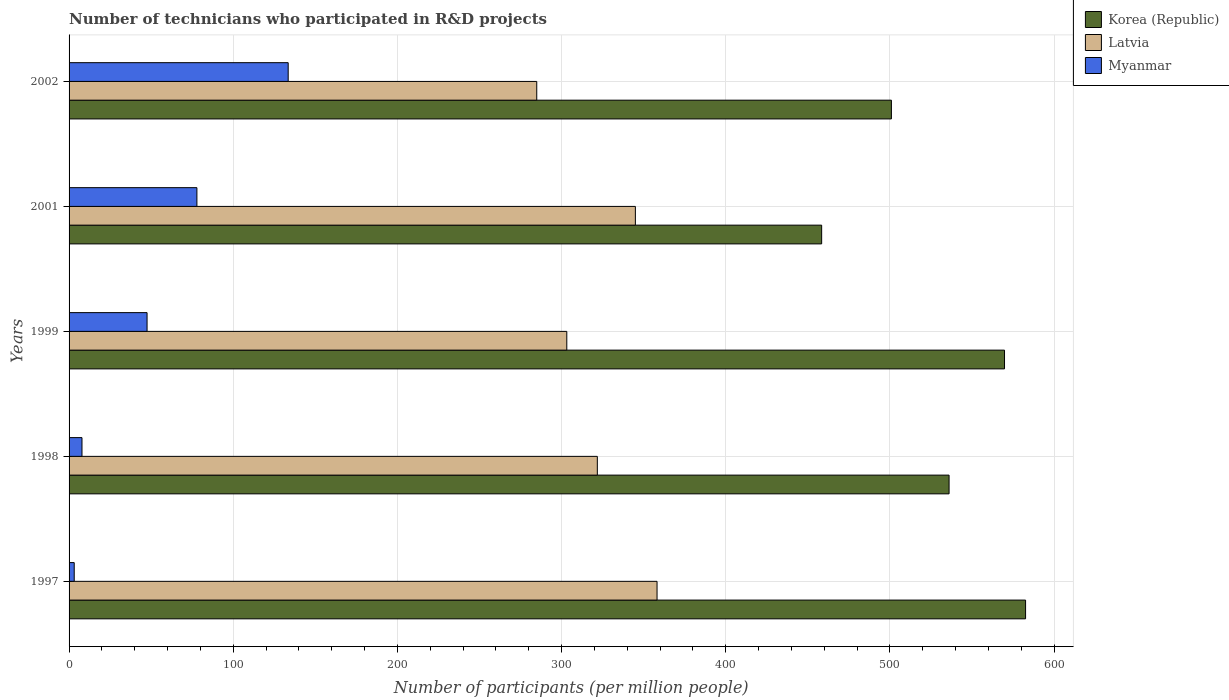How many different coloured bars are there?
Offer a terse response. 3. Are the number of bars per tick equal to the number of legend labels?
Ensure brevity in your answer.  Yes. What is the number of technicians who participated in R&D projects in Korea (Republic) in 2001?
Your response must be concise. 458.44. Across all years, what is the maximum number of technicians who participated in R&D projects in Korea (Republic)?
Make the answer very short. 582.66. Across all years, what is the minimum number of technicians who participated in R&D projects in Latvia?
Provide a succinct answer. 284.88. In which year was the number of technicians who participated in R&D projects in Korea (Republic) minimum?
Provide a short and direct response. 2001. What is the total number of technicians who participated in R&D projects in Latvia in the graph?
Offer a very short reply. 1613. What is the difference between the number of technicians who participated in R&D projects in Latvia in 2001 and that in 2002?
Offer a very short reply. 60.08. What is the difference between the number of technicians who participated in R&D projects in Myanmar in 2001 and the number of technicians who participated in R&D projects in Latvia in 1999?
Your answer should be compact. -225.32. What is the average number of technicians who participated in R&D projects in Myanmar per year?
Provide a succinct answer. 53.97. In the year 1998, what is the difference between the number of technicians who participated in R&D projects in Myanmar and number of technicians who participated in R&D projects in Korea (Republic)?
Keep it short and to the point. -528.19. What is the ratio of the number of technicians who participated in R&D projects in Korea (Republic) in 1998 to that in 1999?
Give a very brief answer. 0.94. Is the difference between the number of technicians who participated in R&D projects in Myanmar in 1998 and 2001 greater than the difference between the number of technicians who participated in R&D projects in Korea (Republic) in 1998 and 2001?
Offer a very short reply. No. What is the difference between the highest and the second highest number of technicians who participated in R&D projects in Myanmar?
Your response must be concise. 55.61. What is the difference between the highest and the lowest number of technicians who participated in R&D projects in Myanmar?
Ensure brevity in your answer.  130.34. In how many years, is the number of technicians who participated in R&D projects in Myanmar greater than the average number of technicians who participated in R&D projects in Myanmar taken over all years?
Give a very brief answer. 2. Is the sum of the number of technicians who participated in R&D projects in Korea (Republic) in 1997 and 1998 greater than the maximum number of technicians who participated in R&D projects in Latvia across all years?
Keep it short and to the point. Yes. What does the 1st bar from the top in 1999 represents?
Ensure brevity in your answer.  Myanmar. What does the 2nd bar from the bottom in 1998 represents?
Your answer should be compact. Latvia. Is it the case that in every year, the sum of the number of technicians who participated in R&D projects in Latvia and number of technicians who participated in R&D projects in Myanmar is greater than the number of technicians who participated in R&D projects in Korea (Republic)?
Your answer should be compact. No. How many bars are there?
Give a very brief answer. 15. How many years are there in the graph?
Provide a short and direct response. 5. What is the difference between two consecutive major ticks on the X-axis?
Offer a terse response. 100. Are the values on the major ticks of X-axis written in scientific E-notation?
Give a very brief answer. No. Does the graph contain grids?
Provide a succinct answer. Yes. How many legend labels are there?
Provide a short and direct response. 3. How are the legend labels stacked?
Your answer should be compact. Vertical. What is the title of the graph?
Ensure brevity in your answer.  Number of technicians who participated in R&D projects. What is the label or title of the X-axis?
Give a very brief answer. Number of participants (per million people). What is the label or title of the Y-axis?
Keep it short and to the point. Years. What is the Number of participants (per million people) of Korea (Republic) in 1997?
Ensure brevity in your answer.  582.66. What is the Number of participants (per million people) in Latvia in 1997?
Your answer should be very brief. 358.17. What is the Number of participants (per million people) of Myanmar in 1997?
Make the answer very short. 3.14. What is the Number of participants (per million people) of Korea (Republic) in 1998?
Keep it short and to the point. 536.06. What is the Number of participants (per million people) of Latvia in 1998?
Provide a succinct answer. 321.79. What is the Number of participants (per million people) in Myanmar in 1998?
Your answer should be very brief. 7.87. What is the Number of participants (per million people) in Korea (Republic) in 1999?
Provide a succinct answer. 569.83. What is the Number of participants (per million people) in Latvia in 1999?
Make the answer very short. 303.19. What is the Number of participants (per million people) of Myanmar in 1999?
Give a very brief answer. 47.51. What is the Number of participants (per million people) in Korea (Republic) in 2001?
Offer a very short reply. 458.44. What is the Number of participants (per million people) of Latvia in 2001?
Provide a short and direct response. 344.97. What is the Number of participants (per million people) of Myanmar in 2001?
Provide a short and direct response. 77.87. What is the Number of participants (per million people) of Korea (Republic) in 2002?
Your response must be concise. 500.92. What is the Number of participants (per million people) of Latvia in 2002?
Offer a very short reply. 284.88. What is the Number of participants (per million people) of Myanmar in 2002?
Provide a short and direct response. 133.48. Across all years, what is the maximum Number of participants (per million people) of Korea (Republic)?
Your answer should be compact. 582.66. Across all years, what is the maximum Number of participants (per million people) of Latvia?
Provide a succinct answer. 358.17. Across all years, what is the maximum Number of participants (per million people) of Myanmar?
Your answer should be compact. 133.48. Across all years, what is the minimum Number of participants (per million people) in Korea (Republic)?
Give a very brief answer. 458.44. Across all years, what is the minimum Number of participants (per million people) in Latvia?
Make the answer very short. 284.88. Across all years, what is the minimum Number of participants (per million people) of Myanmar?
Your response must be concise. 3.14. What is the total Number of participants (per million people) in Korea (Republic) in the graph?
Your answer should be very brief. 2647.91. What is the total Number of participants (per million people) in Latvia in the graph?
Provide a succinct answer. 1613. What is the total Number of participants (per million people) of Myanmar in the graph?
Give a very brief answer. 269.86. What is the difference between the Number of participants (per million people) in Korea (Republic) in 1997 and that in 1998?
Make the answer very short. 46.6. What is the difference between the Number of participants (per million people) in Latvia in 1997 and that in 1998?
Offer a terse response. 36.38. What is the difference between the Number of participants (per million people) in Myanmar in 1997 and that in 1998?
Your answer should be very brief. -4.73. What is the difference between the Number of participants (per million people) in Korea (Republic) in 1997 and that in 1999?
Keep it short and to the point. 12.83. What is the difference between the Number of participants (per million people) of Latvia in 1997 and that in 1999?
Keep it short and to the point. 54.97. What is the difference between the Number of participants (per million people) in Myanmar in 1997 and that in 1999?
Ensure brevity in your answer.  -44.37. What is the difference between the Number of participants (per million people) in Korea (Republic) in 1997 and that in 2001?
Keep it short and to the point. 124.22. What is the difference between the Number of participants (per million people) of Latvia in 1997 and that in 2001?
Your response must be concise. 13.2. What is the difference between the Number of participants (per million people) in Myanmar in 1997 and that in 2001?
Offer a very short reply. -74.73. What is the difference between the Number of participants (per million people) of Korea (Republic) in 1997 and that in 2002?
Ensure brevity in your answer.  81.73. What is the difference between the Number of participants (per million people) of Latvia in 1997 and that in 2002?
Keep it short and to the point. 73.28. What is the difference between the Number of participants (per million people) in Myanmar in 1997 and that in 2002?
Ensure brevity in your answer.  -130.34. What is the difference between the Number of participants (per million people) of Korea (Republic) in 1998 and that in 1999?
Ensure brevity in your answer.  -33.77. What is the difference between the Number of participants (per million people) in Latvia in 1998 and that in 1999?
Your answer should be compact. 18.59. What is the difference between the Number of participants (per million people) of Myanmar in 1998 and that in 1999?
Offer a terse response. -39.64. What is the difference between the Number of participants (per million people) in Korea (Republic) in 1998 and that in 2001?
Your answer should be compact. 77.62. What is the difference between the Number of participants (per million people) in Latvia in 1998 and that in 2001?
Your answer should be compact. -23.18. What is the difference between the Number of participants (per million people) of Myanmar in 1998 and that in 2001?
Offer a very short reply. -70. What is the difference between the Number of participants (per million people) of Korea (Republic) in 1998 and that in 2002?
Give a very brief answer. 35.13. What is the difference between the Number of participants (per million people) of Latvia in 1998 and that in 2002?
Keep it short and to the point. 36.9. What is the difference between the Number of participants (per million people) in Myanmar in 1998 and that in 2002?
Make the answer very short. -125.61. What is the difference between the Number of participants (per million people) of Korea (Republic) in 1999 and that in 2001?
Provide a succinct answer. 111.39. What is the difference between the Number of participants (per million people) of Latvia in 1999 and that in 2001?
Your answer should be very brief. -41.78. What is the difference between the Number of participants (per million people) of Myanmar in 1999 and that in 2001?
Your answer should be compact. -30.36. What is the difference between the Number of participants (per million people) of Korea (Republic) in 1999 and that in 2002?
Provide a succinct answer. 68.91. What is the difference between the Number of participants (per million people) in Latvia in 1999 and that in 2002?
Ensure brevity in your answer.  18.31. What is the difference between the Number of participants (per million people) in Myanmar in 1999 and that in 2002?
Make the answer very short. -85.97. What is the difference between the Number of participants (per million people) of Korea (Republic) in 2001 and that in 2002?
Your response must be concise. -42.48. What is the difference between the Number of participants (per million people) of Latvia in 2001 and that in 2002?
Your response must be concise. 60.08. What is the difference between the Number of participants (per million people) of Myanmar in 2001 and that in 2002?
Provide a succinct answer. -55.61. What is the difference between the Number of participants (per million people) of Korea (Republic) in 1997 and the Number of participants (per million people) of Latvia in 1998?
Keep it short and to the point. 260.87. What is the difference between the Number of participants (per million people) of Korea (Republic) in 1997 and the Number of participants (per million people) of Myanmar in 1998?
Make the answer very short. 574.79. What is the difference between the Number of participants (per million people) of Latvia in 1997 and the Number of participants (per million people) of Myanmar in 1998?
Your response must be concise. 350.3. What is the difference between the Number of participants (per million people) in Korea (Republic) in 1997 and the Number of participants (per million people) in Latvia in 1999?
Make the answer very short. 279.46. What is the difference between the Number of participants (per million people) in Korea (Republic) in 1997 and the Number of participants (per million people) in Myanmar in 1999?
Provide a succinct answer. 535.15. What is the difference between the Number of participants (per million people) of Latvia in 1997 and the Number of participants (per million people) of Myanmar in 1999?
Offer a very short reply. 310.66. What is the difference between the Number of participants (per million people) in Korea (Republic) in 1997 and the Number of participants (per million people) in Latvia in 2001?
Your answer should be compact. 237.69. What is the difference between the Number of participants (per million people) of Korea (Republic) in 1997 and the Number of participants (per million people) of Myanmar in 2001?
Offer a very short reply. 504.79. What is the difference between the Number of participants (per million people) of Latvia in 1997 and the Number of participants (per million people) of Myanmar in 2001?
Make the answer very short. 280.3. What is the difference between the Number of participants (per million people) of Korea (Republic) in 1997 and the Number of participants (per million people) of Latvia in 2002?
Your answer should be very brief. 297.77. What is the difference between the Number of participants (per million people) of Korea (Republic) in 1997 and the Number of participants (per million people) of Myanmar in 2002?
Give a very brief answer. 449.18. What is the difference between the Number of participants (per million people) of Latvia in 1997 and the Number of participants (per million people) of Myanmar in 2002?
Your response must be concise. 224.69. What is the difference between the Number of participants (per million people) of Korea (Republic) in 1998 and the Number of participants (per million people) of Latvia in 1999?
Ensure brevity in your answer.  232.87. What is the difference between the Number of participants (per million people) of Korea (Republic) in 1998 and the Number of participants (per million people) of Myanmar in 1999?
Your answer should be compact. 488.55. What is the difference between the Number of participants (per million people) of Latvia in 1998 and the Number of participants (per million people) of Myanmar in 1999?
Offer a very short reply. 274.28. What is the difference between the Number of participants (per million people) of Korea (Republic) in 1998 and the Number of participants (per million people) of Latvia in 2001?
Your response must be concise. 191.09. What is the difference between the Number of participants (per million people) in Korea (Republic) in 1998 and the Number of participants (per million people) in Myanmar in 2001?
Your answer should be compact. 458.19. What is the difference between the Number of participants (per million people) in Latvia in 1998 and the Number of participants (per million people) in Myanmar in 2001?
Make the answer very short. 243.92. What is the difference between the Number of participants (per million people) in Korea (Republic) in 1998 and the Number of participants (per million people) in Latvia in 2002?
Provide a short and direct response. 251.17. What is the difference between the Number of participants (per million people) in Korea (Republic) in 1998 and the Number of participants (per million people) in Myanmar in 2002?
Your answer should be compact. 402.58. What is the difference between the Number of participants (per million people) of Latvia in 1998 and the Number of participants (per million people) of Myanmar in 2002?
Offer a terse response. 188.31. What is the difference between the Number of participants (per million people) in Korea (Republic) in 1999 and the Number of participants (per million people) in Latvia in 2001?
Offer a very short reply. 224.86. What is the difference between the Number of participants (per million people) of Korea (Republic) in 1999 and the Number of participants (per million people) of Myanmar in 2001?
Your answer should be compact. 491.96. What is the difference between the Number of participants (per million people) in Latvia in 1999 and the Number of participants (per million people) in Myanmar in 2001?
Provide a short and direct response. 225.32. What is the difference between the Number of participants (per million people) in Korea (Republic) in 1999 and the Number of participants (per million people) in Latvia in 2002?
Keep it short and to the point. 284.95. What is the difference between the Number of participants (per million people) of Korea (Republic) in 1999 and the Number of participants (per million people) of Myanmar in 2002?
Ensure brevity in your answer.  436.35. What is the difference between the Number of participants (per million people) in Latvia in 1999 and the Number of participants (per million people) in Myanmar in 2002?
Provide a succinct answer. 169.71. What is the difference between the Number of participants (per million people) in Korea (Republic) in 2001 and the Number of participants (per million people) in Latvia in 2002?
Make the answer very short. 173.56. What is the difference between the Number of participants (per million people) in Korea (Republic) in 2001 and the Number of participants (per million people) in Myanmar in 2002?
Keep it short and to the point. 324.96. What is the difference between the Number of participants (per million people) of Latvia in 2001 and the Number of participants (per million people) of Myanmar in 2002?
Your answer should be very brief. 211.49. What is the average Number of participants (per million people) in Korea (Republic) per year?
Your answer should be compact. 529.58. What is the average Number of participants (per million people) in Latvia per year?
Your answer should be compact. 322.6. What is the average Number of participants (per million people) in Myanmar per year?
Provide a succinct answer. 53.97. In the year 1997, what is the difference between the Number of participants (per million people) of Korea (Republic) and Number of participants (per million people) of Latvia?
Provide a succinct answer. 224.49. In the year 1997, what is the difference between the Number of participants (per million people) in Korea (Republic) and Number of participants (per million people) in Myanmar?
Give a very brief answer. 579.52. In the year 1997, what is the difference between the Number of participants (per million people) of Latvia and Number of participants (per million people) of Myanmar?
Your answer should be compact. 355.03. In the year 1998, what is the difference between the Number of participants (per million people) in Korea (Republic) and Number of participants (per million people) in Latvia?
Your answer should be compact. 214.27. In the year 1998, what is the difference between the Number of participants (per million people) in Korea (Republic) and Number of participants (per million people) in Myanmar?
Offer a very short reply. 528.19. In the year 1998, what is the difference between the Number of participants (per million people) in Latvia and Number of participants (per million people) in Myanmar?
Your answer should be compact. 313.92. In the year 1999, what is the difference between the Number of participants (per million people) of Korea (Republic) and Number of participants (per million people) of Latvia?
Ensure brevity in your answer.  266.64. In the year 1999, what is the difference between the Number of participants (per million people) in Korea (Republic) and Number of participants (per million people) in Myanmar?
Offer a very short reply. 522.32. In the year 1999, what is the difference between the Number of participants (per million people) of Latvia and Number of participants (per million people) of Myanmar?
Your answer should be very brief. 255.68. In the year 2001, what is the difference between the Number of participants (per million people) in Korea (Republic) and Number of participants (per million people) in Latvia?
Your answer should be very brief. 113.47. In the year 2001, what is the difference between the Number of participants (per million people) of Korea (Republic) and Number of participants (per million people) of Myanmar?
Your answer should be compact. 380.57. In the year 2001, what is the difference between the Number of participants (per million people) in Latvia and Number of participants (per million people) in Myanmar?
Your response must be concise. 267.1. In the year 2002, what is the difference between the Number of participants (per million people) in Korea (Republic) and Number of participants (per million people) in Latvia?
Your response must be concise. 216.04. In the year 2002, what is the difference between the Number of participants (per million people) of Korea (Republic) and Number of participants (per million people) of Myanmar?
Your response must be concise. 367.45. In the year 2002, what is the difference between the Number of participants (per million people) in Latvia and Number of participants (per million people) in Myanmar?
Make the answer very short. 151.41. What is the ratio of the Number of participants (per million people) of Korea (Republic) in 1997 to that in 1998?
Your response must be concise. 1.09. What is the ratio of the Number of participants (per million people) in Latvia in 1997 to that in 1998?
Your response must be concise. 1.11. What is the ratio of the Number of participants (per million people) of Myanmar in 1997 to that in 1998?
Your answer should be compact. 0.4. What is the ratio of the Number of participants (per million people) of Korea (Republic) in 1997 to that in 1999?
Make the answer very short. 1.02. What is the ratio of the Number of participants (per million people) in Latvia in 1997 to that in 1999?
Give a very brief answer. 1.18. What is the ratio of the Number of participants (per million people) of Myanmar in 1997 to that in 1999?
Give a very brief answer. 0.07. What is the ratio of the Number of participants (per million people) of Korea (Republic) in 1997 to that in 2001?
Provide a succinct answer. 1.27. What is the ratio of the Number of participants (per million people) of Latvia in 1997 to that in 2001?
Your answer should be compact. 1.04. What is the ratio of the Number of participants (per million people) in Myanmar in 1997 to that in 2001?
Ensure brevity in your answer.  0.04. What is the ratio of the Number of participants (per million people) of Korea (Republic) in 1997 to that in 2002?
Your response must be concise. 1.16. What is the ratio of the Number of participants (per million people) in Latvia in 1997 to that in 2002?
Provide a succinct answer. 1.26. What is the ratio of the Number of participants (per million people) in Myanmar in 1997 to that in 2002?
Provide a succinct answer. 0.02. What is the ratio of the Number of participants (per million people) in Korea (Republic) in 1998 to that in 1999?
Make the answer very short. 0.94. What is the ratio of the Number of participants (per million people) in Latvia in 1998 to that in 1999?
Make the answer very short. 1.06. What is the ratio of the Number of participants (per million people) of Myanmar in 1998 to that in 1999?
Provide a short and direct response. 0.17. What is the ratio of the Number of participants (per million people) in Korea (Republic) in 1998 to that in 2001?
Your response must be concise. 1.17. What is the ratio of the Number of participants (per million people) in Latvia in 1998 to that in 2001?
Your answer should be very brief. 0.93. What is the ratio of the Number of participants (per million people) in Myanmar in 1998 to that in 2001?
Offer a very short reply. 0.1. What is the ratio of the Number of participants (per million people) of Korea (Republic) in 1998 to that in 2002?
Your answer should be very brief. 1.07. What is the ratio of the Number of participants (per million people) in Latvia in 1998 to that in 2002?
Offer a very short reply. 1.13. What is the ratio of the Number of participants (per million people) of Myanmar in 1998 to that in 2002?
Your answer should be compact. 0.06. What is the ratio of the Number of participants (per million people) of Korea (Republic) in 1999 to that in 2001?
Offer a terse response. 1.24. What is the ratio of the Number of participants (per million people) of Latvia in 1999 to that in 2001?
Your answer should be compact. 0.88. What is the ratio of the Number of participants (per million people) in Myanmar in 1999 to that in 2001?
Your response must be concise. 0.61. What is the ratio of the Number of participants (per million people) of Korea (Republic) in 1999 to that in 2002?
Your answer should be compact. 1.14. What is the ratio of the Number of participants (per million people) in Latvia in 1999 to that in 2002?
Provide a succinct answer. 1.06. What is the ratio of the Number of participants (per million people) of Myanmar in 1999 to that in 2002?
Your answer should be very brief. 0.36. What is the ratio of the Number of participants (per million people) in Korea (Republic) in 2001 to that in 2002?
Provide a succinct answer. 0.92. What is the ratio of the Number of participants (per million people) in Latvia in 2001 to that in 2002?
Your response must be concise. 1.21. What is the ratio of the Number of participants (per million people) of Myanmar in 2001 to that in 2002?
Make the answer very short. 0.58. What is the difference between the highest and the second highest Number of participants (per million people) of Korea (Republic)?
Make the answer very short. 12.83. What is the difference between the highest and the second highest Number of participants (per million people) in Latvia?
Make the answer very short. 13.2. What is the difference between the highest and the second highest Number of participants (per million people) of Myanmar?
Provide a short and direct response. 55.61. What is the difference between the highest and the lowest Number of participants (per million people) in Korea (Republic)?
Offer a very short reply. 124.22. What is the difference between the highest and the lowest Number of participants (per million people) in Latvia?
Your answer should be compact. 73.28. What is the difference between the highest and the lowest Number of participants (per million people) of Myanmar?
Keep it short and to the point. 130.34. 